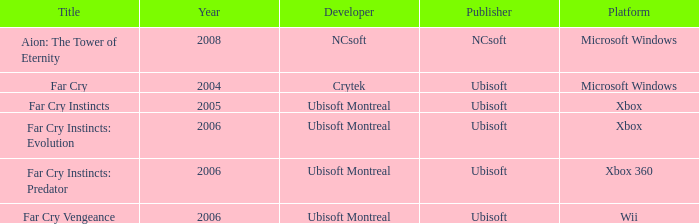Which developer has xbox 360 as the platform? Ubisoft Montreal. 